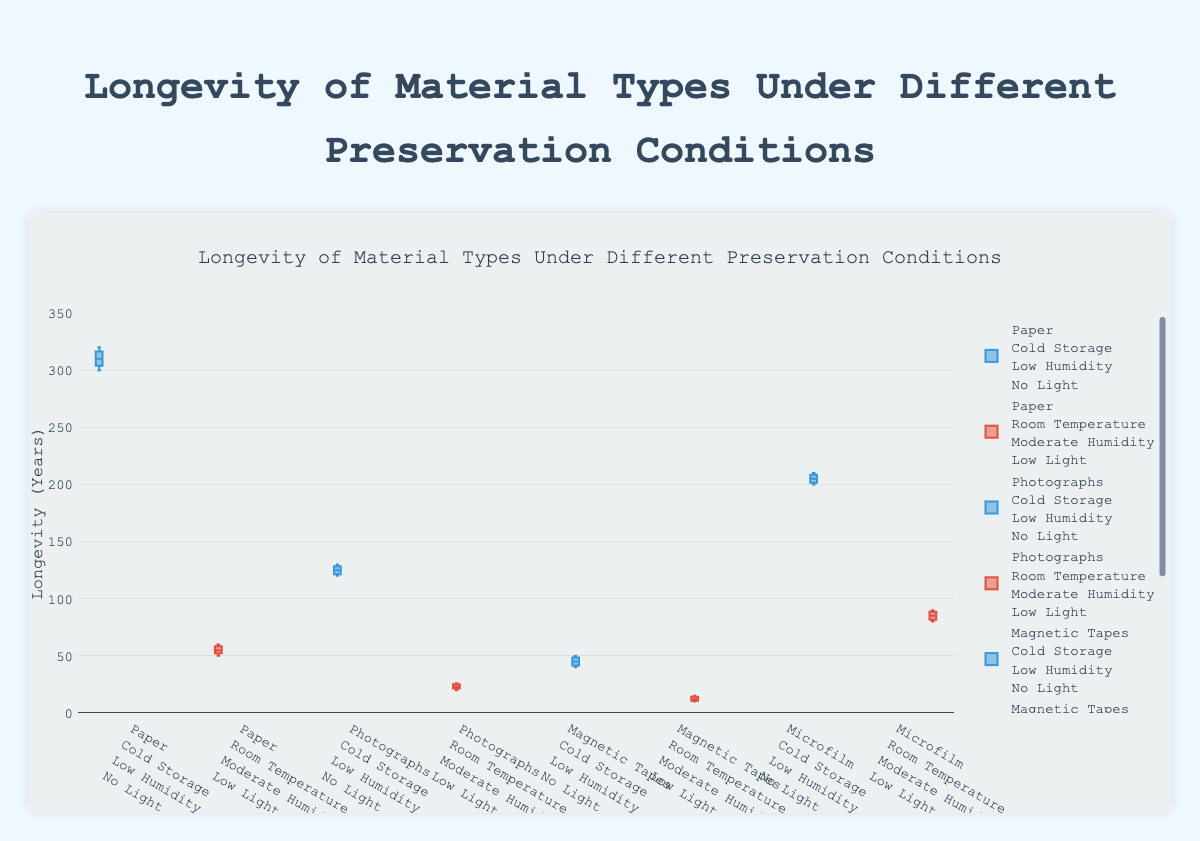How many different preservation conditions are represented in the box plot? Count the number of unique labels on the x-axis of the box plot, each representing a specific preservation condition (e.g., material type, temperature, humidity, light exposure).
Answer: 8 What's the median longevity of Paper under Cold Storage and Low Humidity with No Light exposure? Locate the box plot for Paper under Cold Storage, Low Humidity, and No Light conditions. The median is the line inside the box.
Answer: 310 years Which material type shows the highest longevity under Room Temperature conditions? Compare the upper whiskers of the box plots under Room Temperature conditions. The longest whisker indicates the highest longevity.
Answer: Microfilm What is the interquartile range (IQR) for Photographs under Cold Storage conditions? Locate the box plot for Photographs under Cold Storage, Low Humidity, and No Light. The IQR is the difference between the upper and lower quartiles (top and bottom of the box).
Answer: 8 years (upper quartile: 128, lower quartile: 120) Which preservation condition results in the lowest median longevity for Magnetic Tapes? Compare the medians (lines inside the boxes) of the box plots for Magnetic Tapes under different conditions. The lowest median indicates the condition with the lowest longevity.
Answer: Room Temperature, Moderate Humidity, Low Light How does the longevity of Paper compare between Cold Storage and Room Temperature conditions? Compare the values of the box plots for Paper under both Cold Storage and Room Temperature. Notice the median, IQR, and whiskers.
Answer: Cold Storage is significantly higher than Room Temperature What's the range of longevity for Microfilm under Cold Storage conditions? Locate the box plot for Microfilm under Cold Storage, Low Humidity, and No Light. The range is the difference between the maximum and minimum values (top and bottom whiskers).
Answer: 10 years (maximum: 210, minimum: 200) Which material type shows the smallest variation in longevity under any preservation condition? Look for the box plot with the shortest box and whiskers, indicating the smallest variation in longevity.
Answer: Paper under Cold Storage What is the average longevity of all the Cold Storage conditions for Photographs and Magnetic Tapes combined? For Photographs: (120 + 130 + 125 + 128 + 122) / 5 = 125 years. For Magnetic Tapes: (40 + 45 + 50 + 42 + 48) / 5 = 45 years. Average of both: (125 + 45) / 2 = 85 years.
Answer: 85 years 